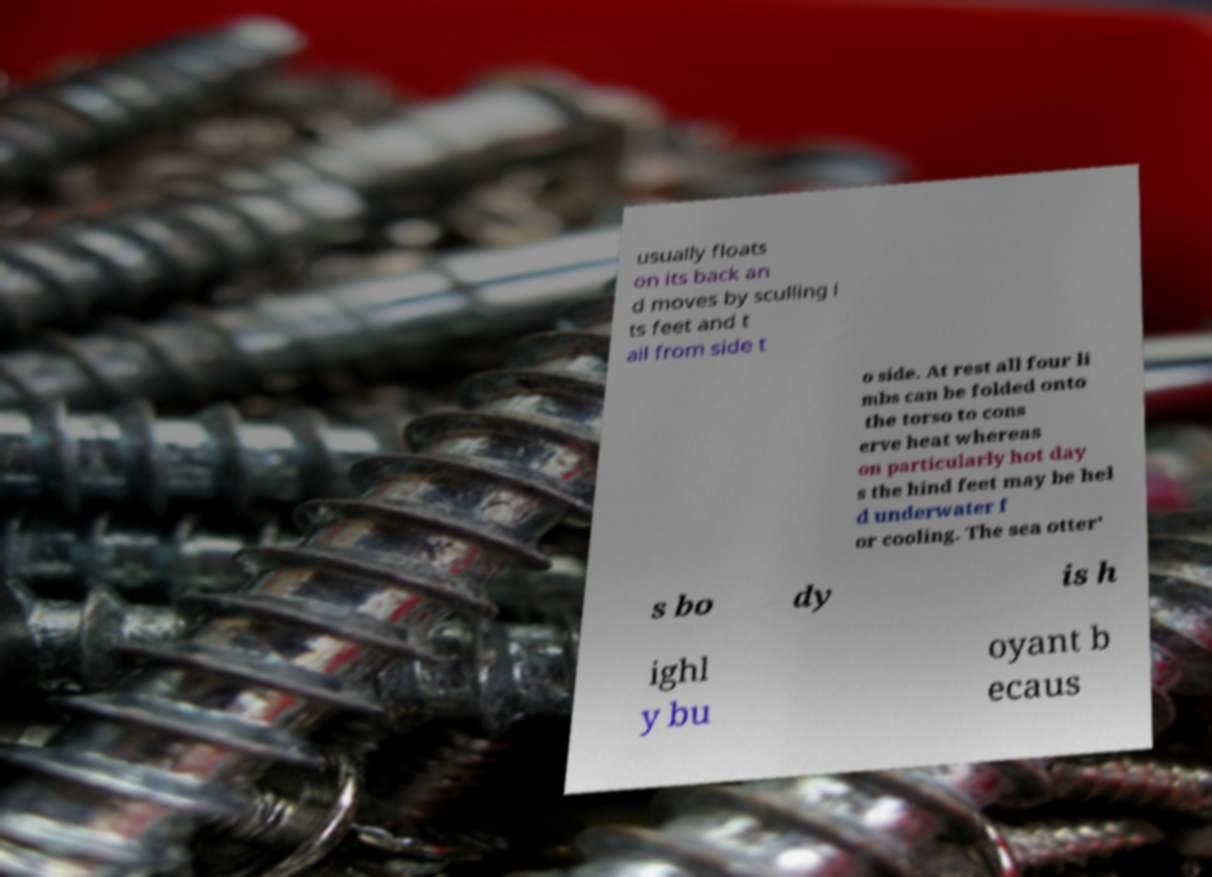Can you read and provide the text displayed in the image?This photo seems to have some interesting text. Can you extract and type it out for me? usually floats on its back an d moves by sculling i ts feet and t ail from side t o side. At rest all four li mbs can be folded onto the torso to cons erve heat whereas on particularly hot day s the hind feet may be hel d underwater f or cooling. The sea otter' s bo dy is h ighl y bu oyant b ecaus 